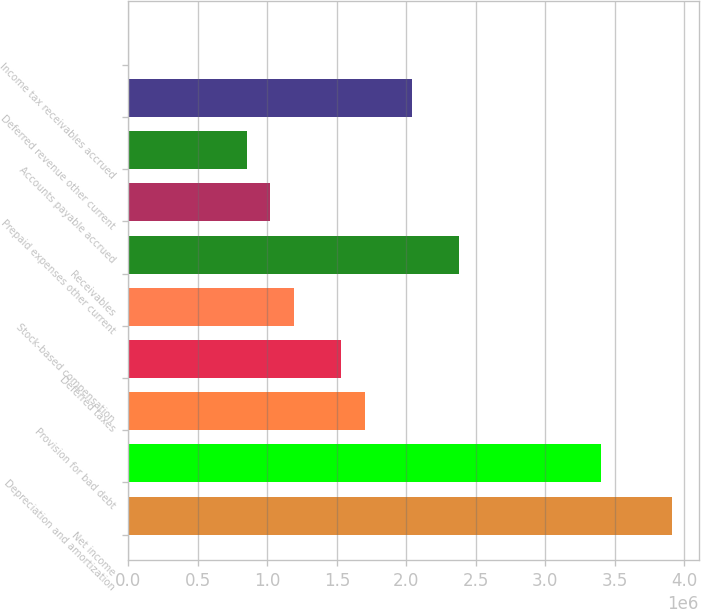Convert chart. <chart><loc_0><loc_0><loc_500><loc_500><bar_chart><fcel>Net income<fcel>Depreciation and amortization<fcel>Provision for bad debt<fcel>Deferred taxes<fcel>Stock-based compensation<fcel>Receivables<fcel>Prepaid expenses other current<fcel>Accounts payable accrued<fcel>Deferred revenue other current<fcel>Income tax receivables accrued<nl><fcel>3.90983e+06<fcel>3.39987e+06<fcel>1.7e+06<fcel>1.53001e+06<fcel>1.19004e+06<fcel>2.37995e+06<fcel>1.02005e+06<fcel>850064<fcel>2.03997e+06<fcel>129<nl></chart> 